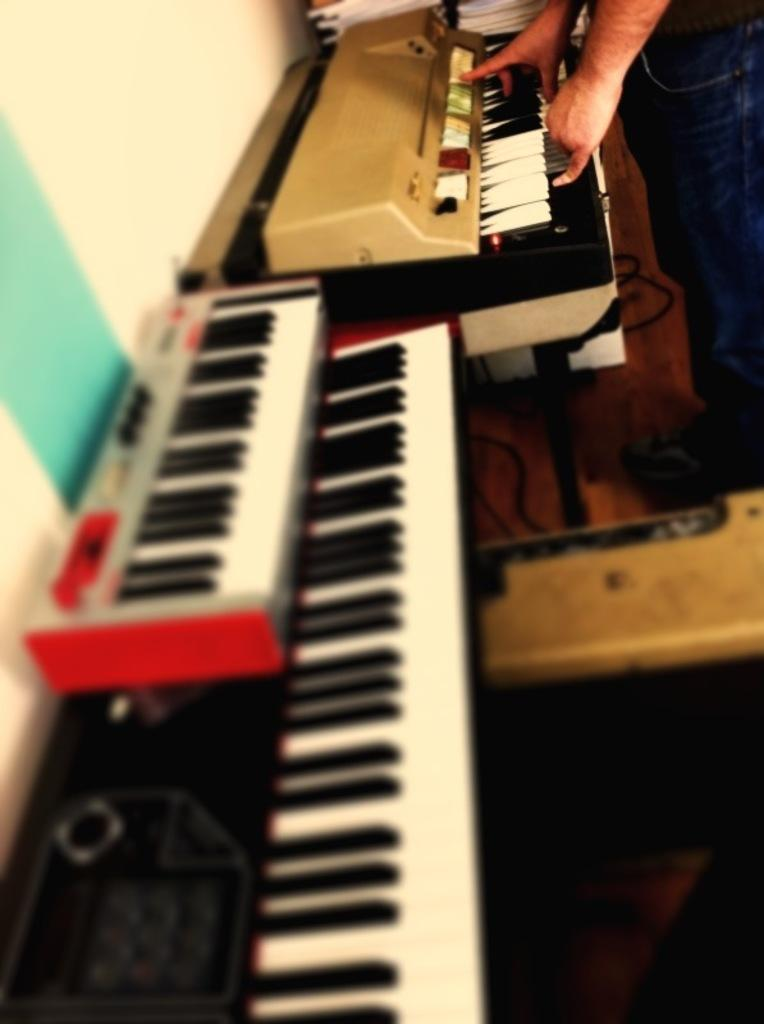How many keyboards are visible in the image? There are three keyboards in the image. What is one person doing with one of the keyboards? One person is playing one of the keyboards. What can be seen in the background of the image? There are books in the background of the image. What type of furniture is visible in the image? There is no furniture mentioned or visible in the image. How many cups can be seen in the image? There are no cups present in the image. 